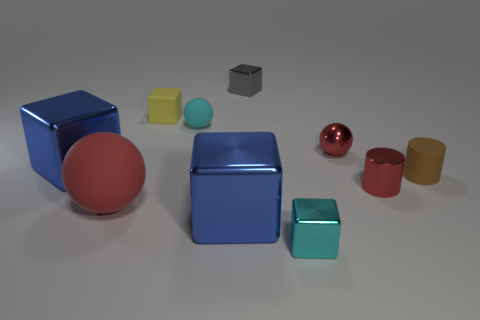What is the material of the small object left of the cyan ball on the left side of the tiny brown rubber object?
Make the answer very short. Rubber. Are there fewer brown matte cylinders that are in front of the brown cylinder than small cyan things that are on the right side of the tiny gray block?
Give a very brief answer. Yes. What number of purple things are rubber things or small blocks?
Ensure brevity in your answer.  0. Are there an equal number of blocks in front of the large red matte object and large blue blocks?
Make the answer very short. Yes. What number of things are tiny gray metal things or large objects that are to the right of the red matte thing?
Your answer should be compact. 2. Do the metallic cylinder and the big matte thing have the same color?
Provide a short and direct response. Yes. Is there a gray cube that has the same material as the small yellow object?
Ensure brevity in your answer.  No. What color is the other rubber thing that is the same shape as the tiny gray object?
Your answer should be very brief. Yellow. Does the tiny cyan block have the same material as the cyan object that is behind the large red sphere?
Offer a very short reply. No. The small cyan thing that is in front of the tiny sphere that is right of the cyan cube is what shape?
Your answer should be compact. Cube. 